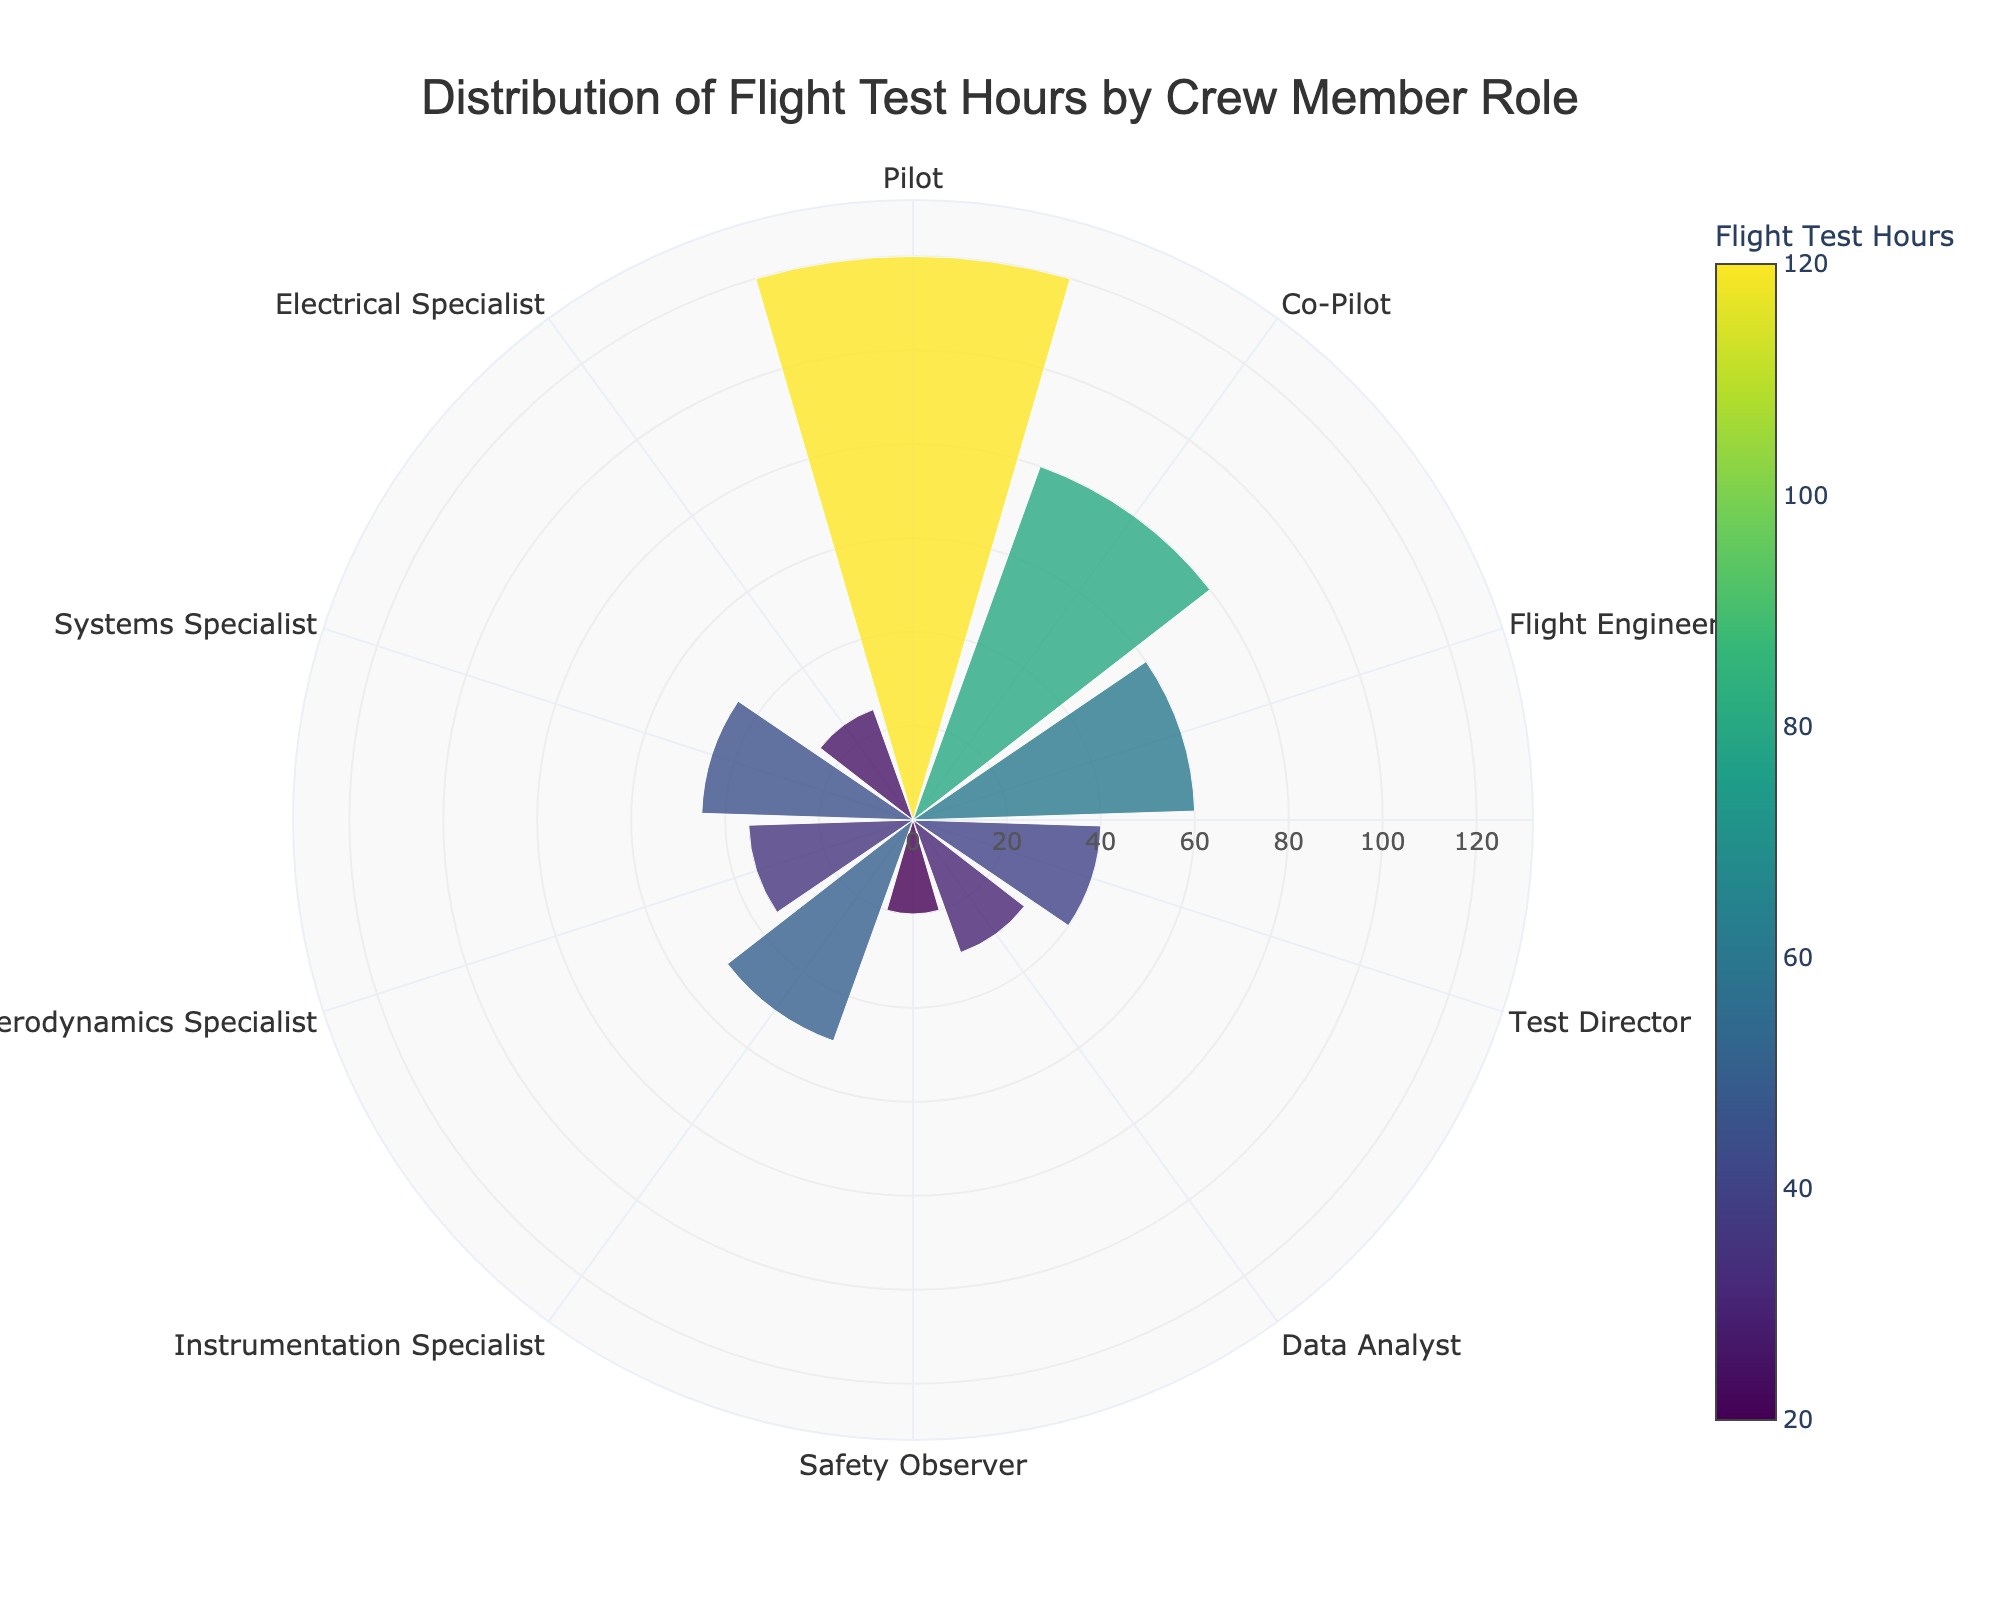What is the title of the figure? The title is displayed at the top of the figure and provides a summary of what the figure represents. The title is "Distribution of Flight Test Hours by Crew Member Role".
Answer: Distribution of Flight Test Hours by Crew Member Role Which role has the highest number of flight test hours? The role with the highest number of flight test hours is indicated by the longest bar, which is that of the Pilot with 120 hours.
Answer: Pilot How many roles have more than 50 flight test hours? We need to count all the bars that extend beyond the 50-hour mark, which are Pilot with 120 hours, Co-Pilot with 80 hours, and Flight Engineer with 60 hours.
Answer: 3 What is the combined flight test hours for the Data Analyst and Electrical Specialist roles? The Data Analyst has 30 hours and the Electrical Specialist has 25 hours. Adding these together, we get 30 + 25 = 55 hours.
Answer: 55 hours Which role has the lowest number of flight test hours, and how many hours is that? The shortest bar representing the role with the least number of hours is the Safety Observer with 20 hours.
Answer: Safety Observer with 20 hours What is the difference in flight test hours between the Flight Engineer and the Co-Pilot? The Flight Engineer has 60 hours and the Co-Pilot has 80 hours. The difference is 80 - 60 = 20 hours.
Answer: 20 hours How does the number of hours for the Systems Specialist compare to that for the Aerodynamics Specialist? The Systems Specialist has 45 hours, while the Aerodynamics Specialist has 35 hours. The Systems Specialist has 10 more hours.
Answer: Systems Specialist has 10 more hours What is the average number of flight test hours across all roles? Summing all the flight test hours (120 + 80 + 60 + 40 + 30 + 20 + 50 + 35 + 45 + 25 = 505) and then dividing by the number of roles (10) gives an average of 505 / 10 = 50.5 hours.
Answer: 50.5 hours How many roles have flight test hours within the range of 30 to 60? Identifying the bars with flight test hours in this range, we have Flight Engineer (60), Data Analyst (30), Instrumentation Specialist (50), Aerodynamics Specialist (35), and Systems Specialist (45), totaling 5 roles.
Answer: 5 